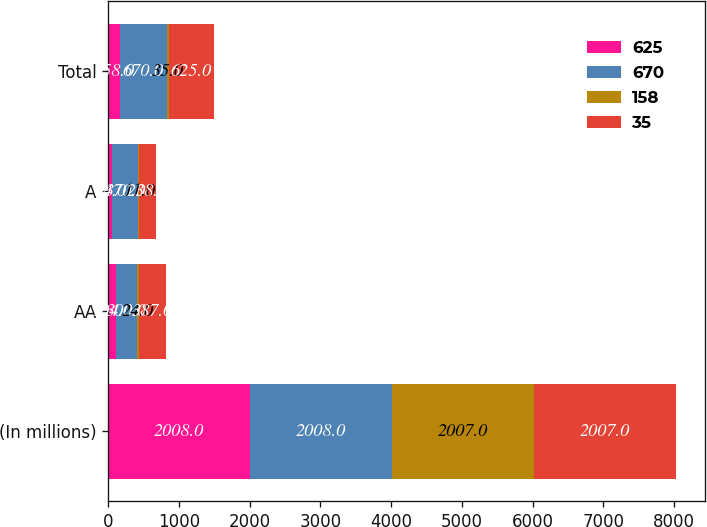<chart> <loc_0><loc_0><loc_500><loc_500><stacked_bar_chart><ecel><fcel>(In millions)<fcel>AA<fcel>A<fcel>Total<nl><fcel>625<fcel>2008<fcel>104<fcel>54<fcel>158<nl><fcel>670<fcel>2008<fcel>300<fcel>370<fcel>670<nl><fcel>158<fcel>2007<fcel>24<fcel>11<fcel>35<nl><fcel>35<fcel>2007<fcel>387<fcel>238<fcel>625<nl></chart> 